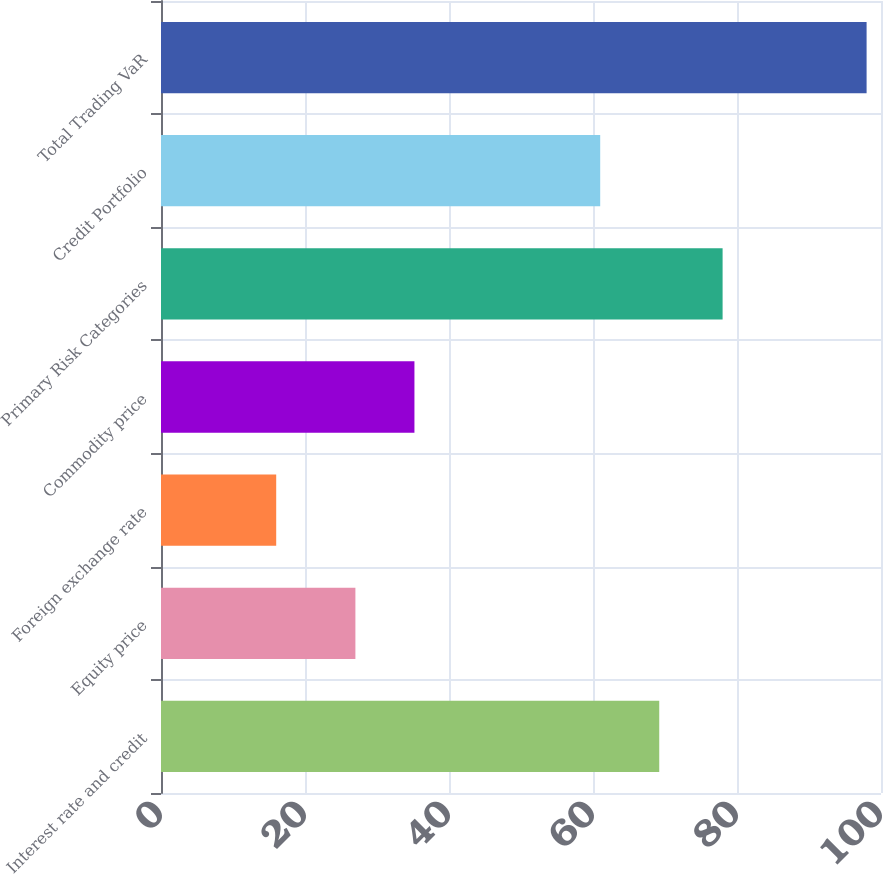Convert chart. <chart><loc_0><loc_0><loc_500><loc_500><bar_chart><fcel>Interest rate and credit<fcel>Equity price<fcel>Foreign exchange rate<fcel>Commodity price<fcel>Primary Risk Categories<fcel>Credit Portfolio<fcel>Total Trading VaR<nl><fcel>69.2<fcel>27<fcel>16<fcel>35.2<fcel>78<fcel>61<fcel>98<nl></chart> 